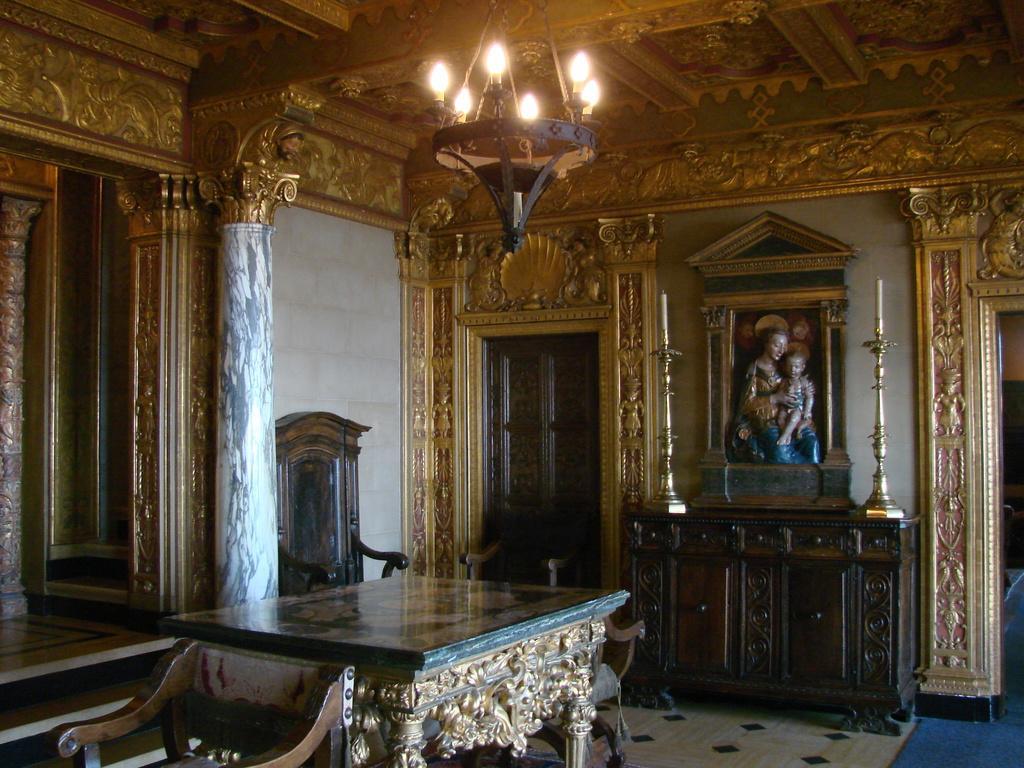Describe this image in one or two sentences. This is a picture of inside of the building, in this image there is a table and chairs. And in the center there is a door, candles and some stands and there are statues, wall, pillars, chair. And at the bottom there is floor and carpet, at the top there is ceiling and there are lights and chandelier. 